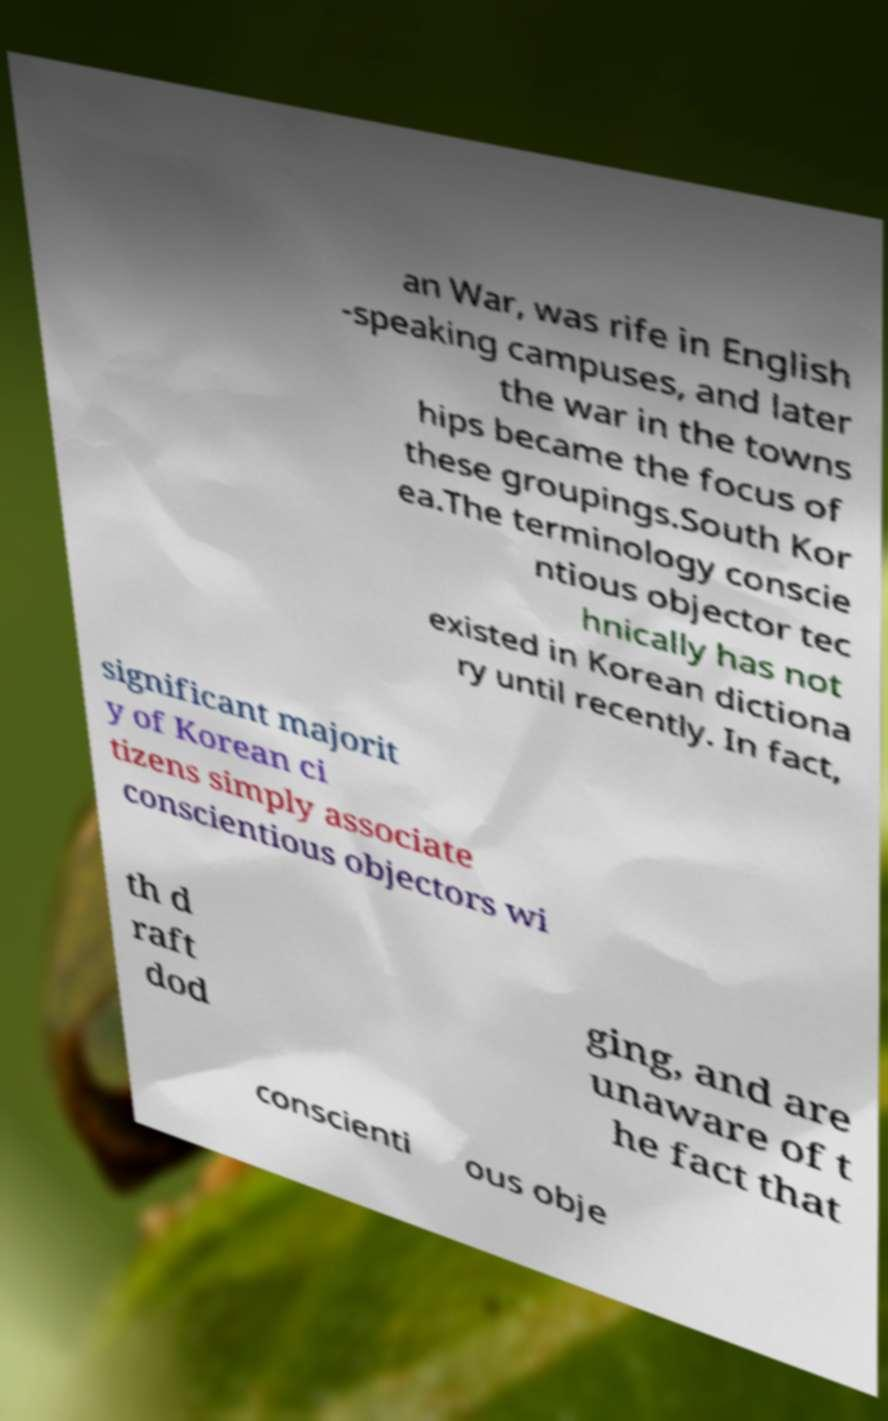Can you read and provide the text displayed in the image?This photo seems to have some interesting text. Can you extract and type it out for me? an War, was rife in English -speaking campuses, and later the war in the towns hips became the focus of these groupings.South Kor ea.The terminology conscie ntious objector tec hnically has not existed in Korean dictiona ry until recently. In fact, significant majorit y of Korean ci tizens simply associate conscientious objectors wi th d raft dod ging, and are unaware of t he fact that conscienti ous obje 